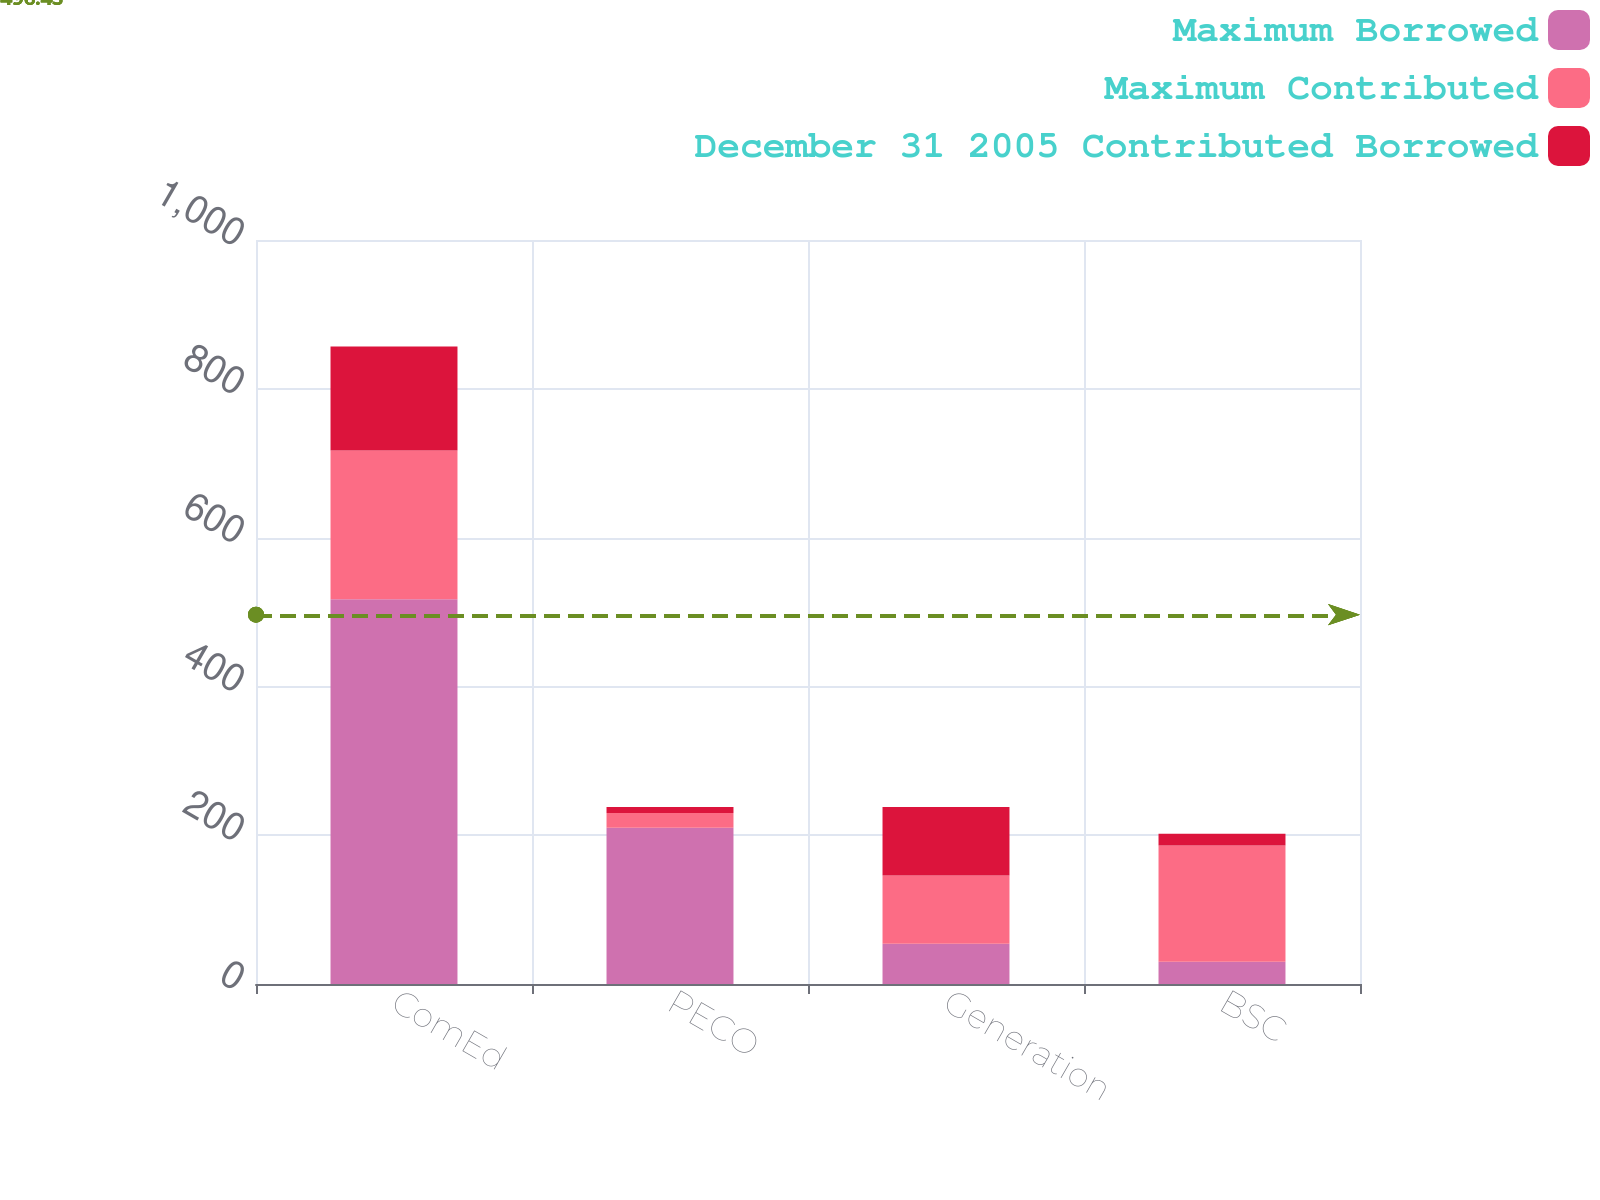Convert chart to OTSL. <chart><loc_0><loc_0><loc_500><loc_500><stacked_bar_chart><ecel><fcel>ComEd<fcel>PECO<fcel>Generation<fcel>BSC<nl><fcel>Maximum Borrowed<fcel>517<fcel>210<fcel>54<fcel>30<nl><fcel>Maximum Contributed<fcel>200<fcel>20<fcel>92<fcel>156<nl><fcel>December 31 2005 Contributed Borrowed<fcel>140<fcel>8<fcel>92<fcel>16<nl></chart> 